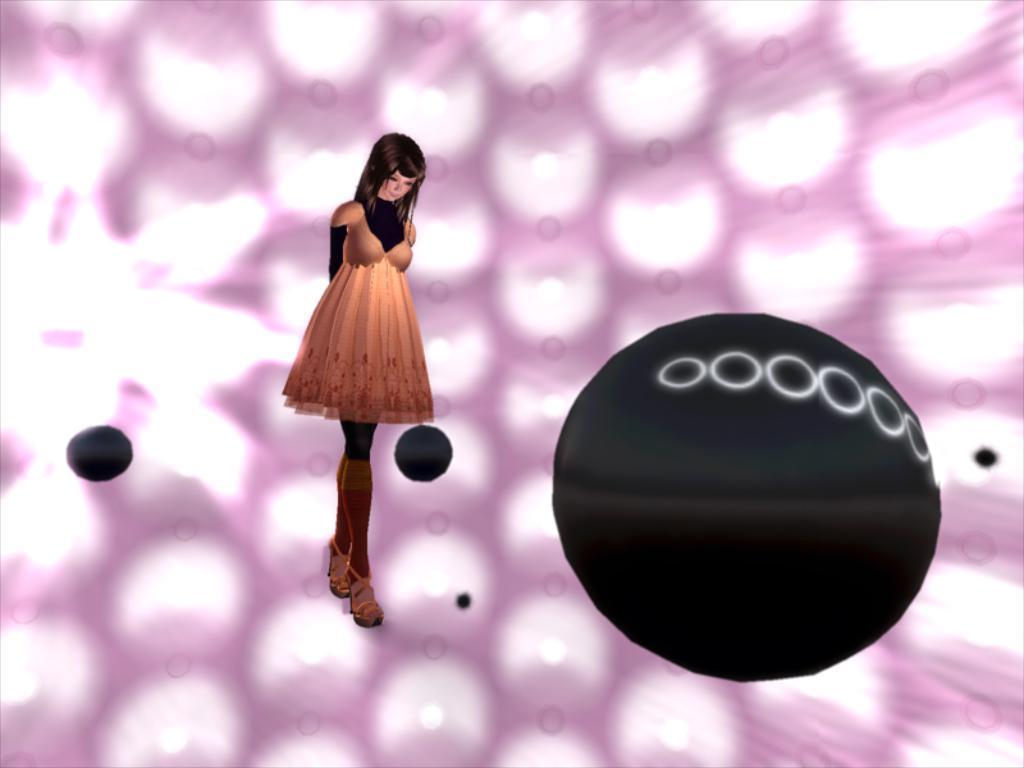How would you summarize this image in a sentence or two? In this image I think it is a graphic. The background is pink and white color. There are black color objects. There is a girl standing. 